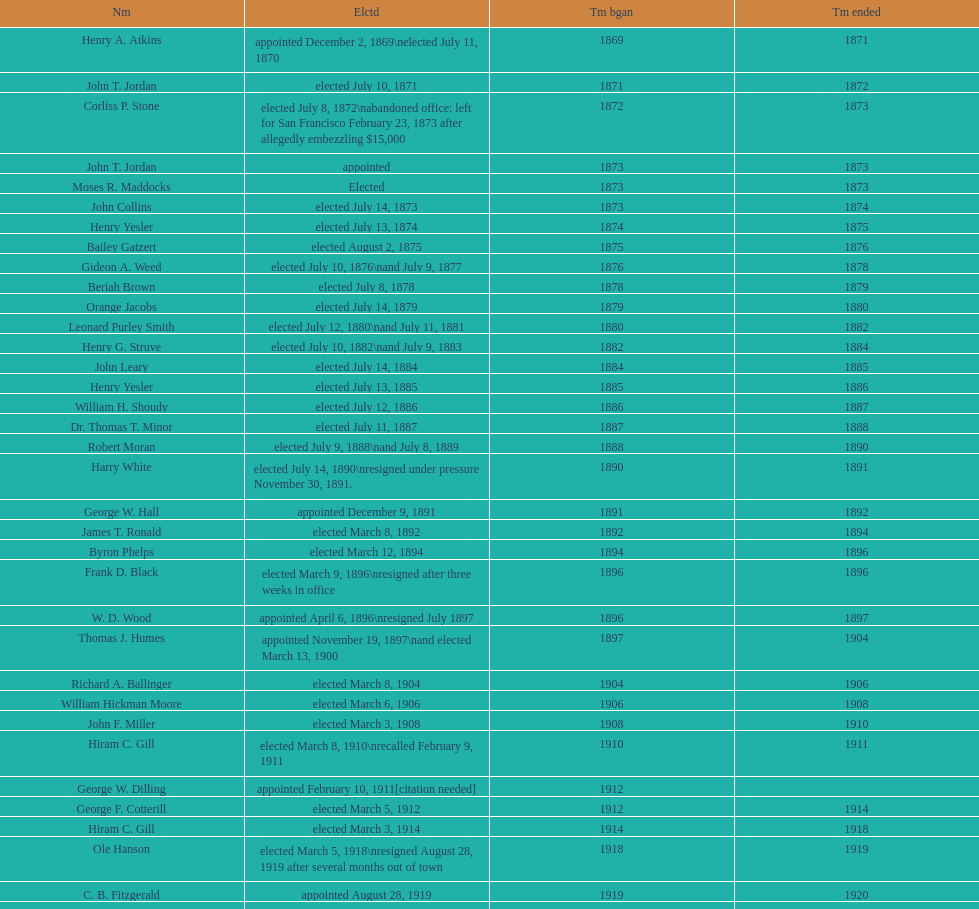Who commenced their term during 1890? Harry White. 